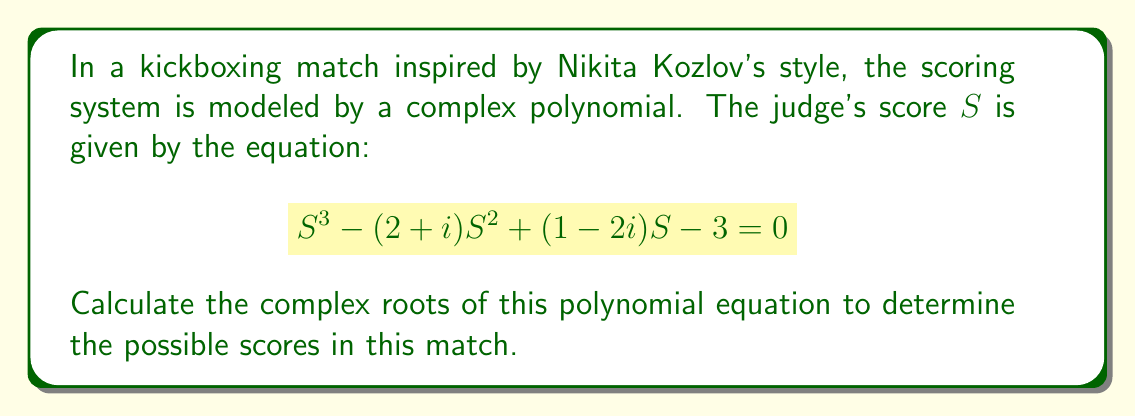Can you solve this math problem? To find the complex roots of this cubic equation, we'll use the following steps:

1) First, we'll use the cubic formula. For a cubic equation in the form $ax^3 + bx^2 + cx + d = 0$, we have:

   $a = 1$, $b = -(2+i)$, $c = 1-2i$, $d = -3$

2) Calculate $p$ and $q$:
   $$p = \frac{3ac-b^2}{3a^2} = \frac{3(1)(1-2i)-(-(2+i))^2}{3(1)^2} = \frac{3-6i-4-4i+1}{3} = -\frac{1+10i}{3}$$
   $$q = \frac{2b^3-9abc+27a^2d}{27a^3} = \frac{2(-(2+i))^3-9(1)(-(2+i))(1-2i)+27(1)^2(-3)}{27(1)^3}$$
   $$= \frac{-8-12i+1-27+54i-81}{27} = -\frac{115+42i}{27}$$

3) Calculate the discriminant $\Delta$:
   $$\Delta = (\frac{q}{2})^2 + (\frac{p}{3})^3$$

4) Calculate the cube roots:
   $$u = \sqrt[3]{-\frac{q}{2} + \sqrt{\Delta}}$$
   $$v = \sqrt[3]{-\frac{q}{2} - \sqrt{\Delta}}$$

5) The three roots are given by:
   $$S_1 = u + v - \frac{b}{3a}$$
   $$S_2 = -\frac{1}{2}(u+v) - \frac{b}{3a} + \frac{i\sqrt{3}}{2}(u-v)$$
   $$S_3 = -\frac{1}{2}(u+v) - \frac{b}{3a} - \frac{i\sqrt{3}}{2}(u-v)$$

6) Calculating these values numerically (which would typically be done with a computer algebra system) gives us the roots.
Answer: $S_1 \approx 2.23 + 0.51i$, $S_2 \approx -0.11 + 1.24i$, $S_3 \approx -0.12 - 0.75i$ 